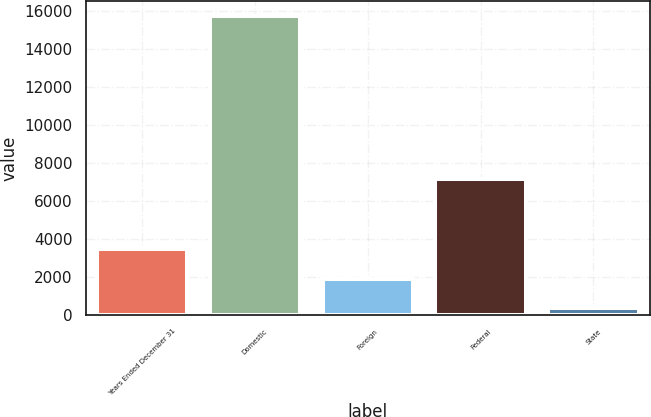Convert chart. <chart><loc_0><loc_0><loc_500><loc_500><bar_chart><fcel>Years Ended December 31<fcel>Domestic<fcel>Foreign<fcel>Federal<fcel>State<nl><fcel>3446<fcel>15730<fcel>1910.5<fcel>7136<fcel>375<nl></chart> 